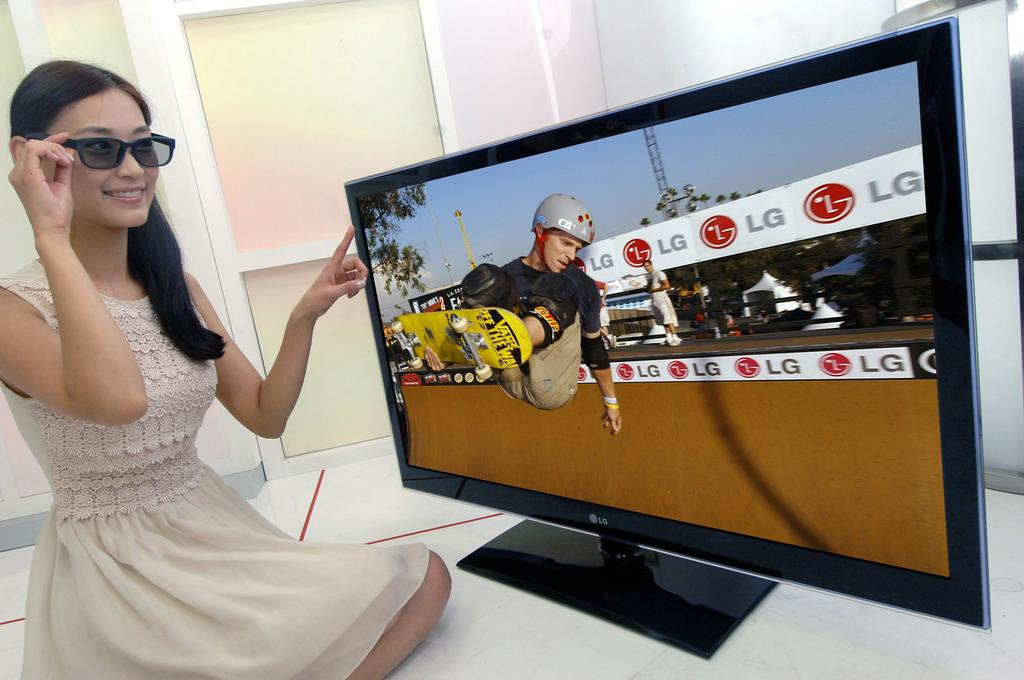<image>
Relay a brief, clear account of the picture shown. A woman in sunglasses in front of a TV screen on which the letters LG are visible. 